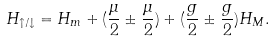<formula> <loc_0><loc_0><loc_500><loc_500>H _ { \uparrow / \downarrow } = H _ { m } + ( \frac { \mu } { 2 } \pm \frac { \mu } { 2 } ) + ( \frac { g } { 2 } \pm \frac { g } { 2 } ) H _ { M } .</formula> 